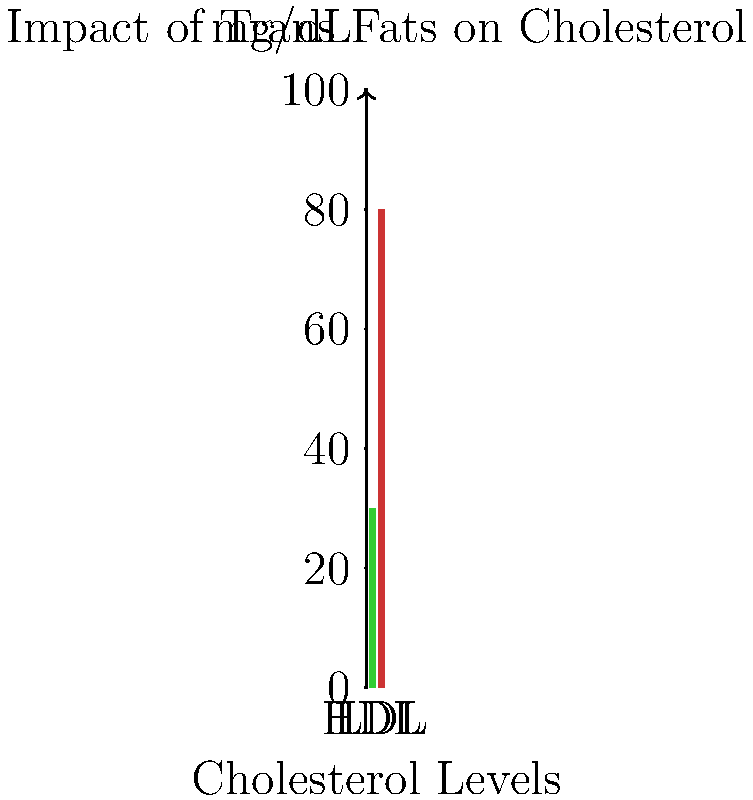Based on the infographic, which type of cholesterol is most negatively affected by the consumption of trans fats, and approximately how much higher is it compared to the healthier level shown? To answer this question, we need to analyze the infographic and understand its components:

1. The infographic shows two bars representing cholesterol levels:
   - A green bar on the left, labeled "HDL" (High-Density Lipoprotein)
   - A red bar on the right, labeled "LDL" (Low-Density Lipoprotein)

2. The y-axis represents cholesterol levels in mg/dL.

3. The green HDL bar reaches approximately 30 mg/dL.

4. The red LDL bar reaches approximately 80 mg/dL.

5. In the context of trans fat consumption:
   - HDL is often referred to as "good" cholesterol
   - LDL is often referred to as "bad" cholesterol

6. Trans fats are known to raise LDL (bad) cholesterol levels while lowering HDL (good) cholesterol levels.

7. The infographic shows a significantly higher level of LDL compared to HDL, which is consistent with the effects of trans fat consumption.

8. To calculate the difference:
   LDL level (80 mg/dL) - HDL level (30 mg/dL) = 50 mg/dL

9. This means the LDL level is approximately 50 mg/dL higher than the HDL level.

Based on this analysis, we can conclude that LDL cholesterol is most negatively affected by trans fats, as indicated by its significantly higher level in the infographic.
Answer: LDL cholesterol, approximately 50 mg/dL higher 